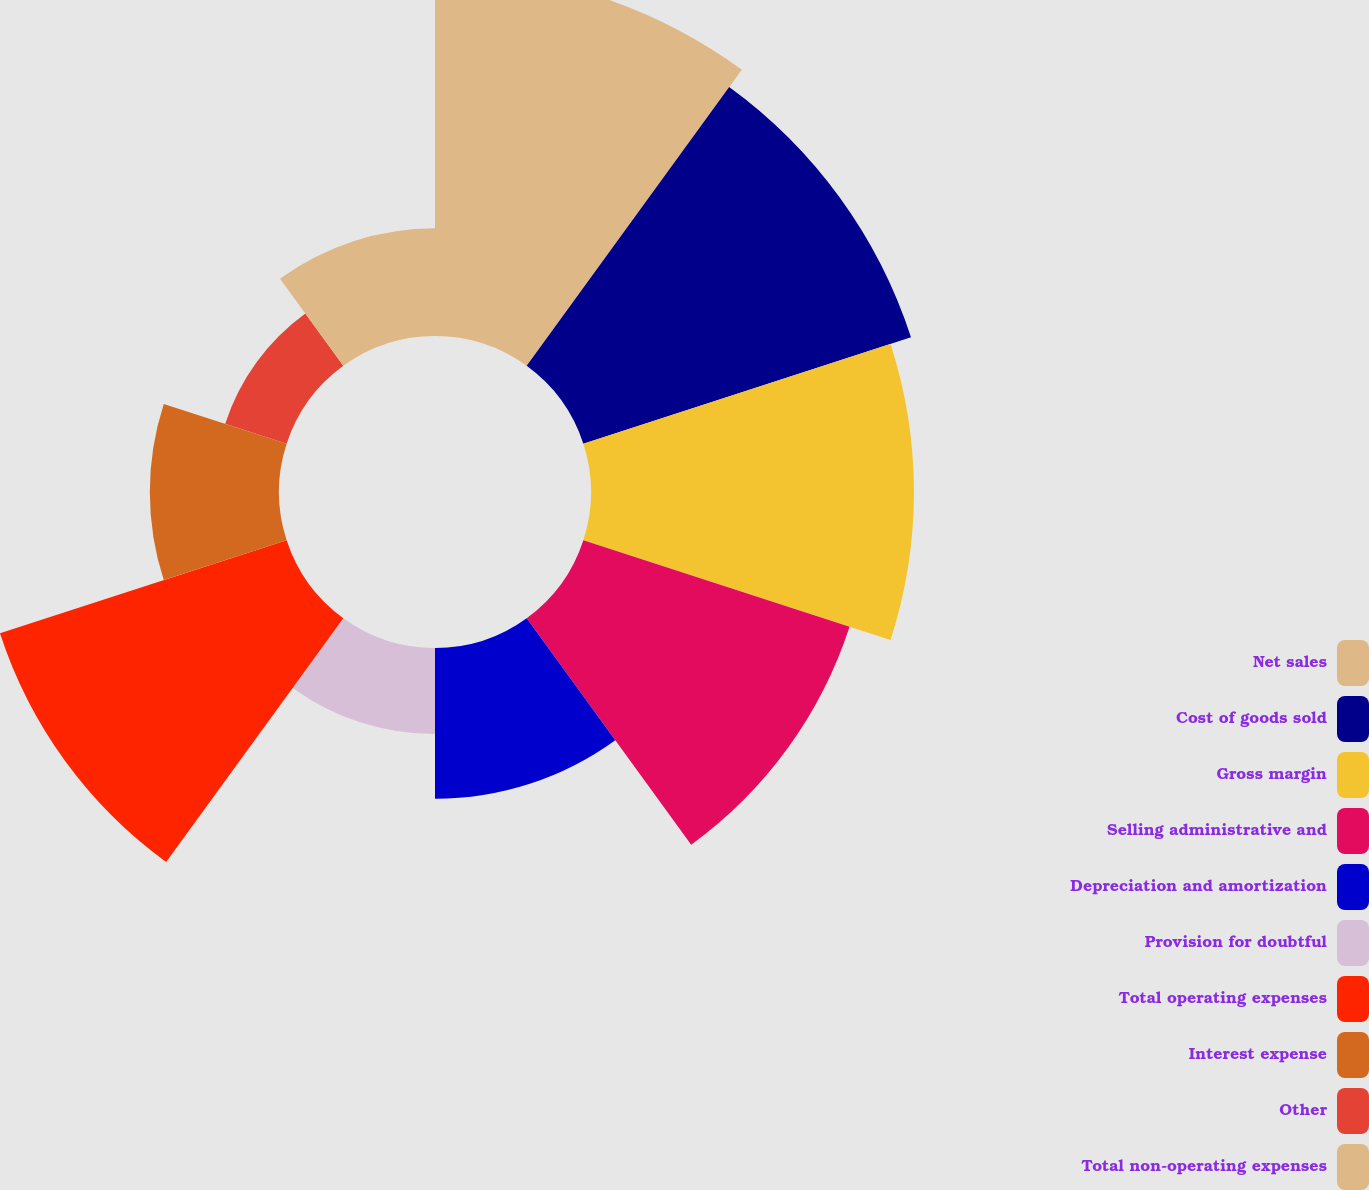<chart> <loc_0><loc_0><loc_500><loc_500><pie_chart><fcel>Net sales<fcel>Cost of goods sold<fcel>Gross margin<fcel>Selling administrative and<fcel>Depreciation and amortization<fcel>Provision for doubtful<fcel>Total operating expenses<fcel>Interest expense<fcel>Other<fcel>Total non-operating expenses<nl><fcel>17.0%<fcel>16.0%<fcel>15.0%<fcel>13.0%<fcel>7.0%<fcel>4.0%<fcel>14.0%<fcel>6.0%<fcel>3.0%<fcel>5.0%<nl></chart> 